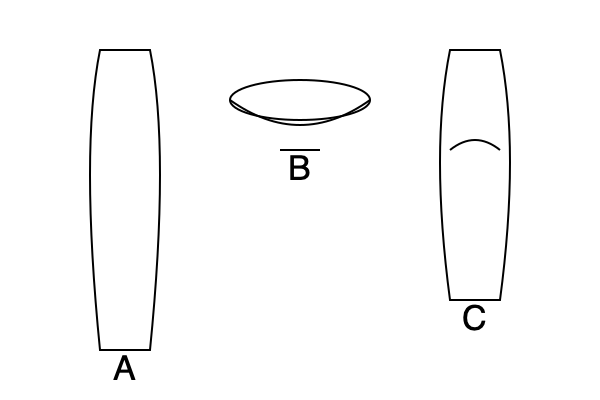Identify the ancient Greek pottery shapes illustrated in the image above and match them to their correct names: Amphora, Kylix, and Hydria. Which shape is specifically designed for mixing wine and water? To answer this question, we need to analyze the characteristics of each pottery shape and match them to their names:

1. Shape A: This is an Amphora. It has a tall, slender body with two handles and a narrow neck. Amphorae were primarily used for storing and transporting liquids like wine and olive oil.

2. Shape B: This is a Kylix. It's a wide, shallow drinking cup with a broad bowl, a stem, and a foot. The Kylix was specifically designed for drinking wine at symposia (ancient Greek drinking parties).

3. Shape C: This is a Hydria. It has a rounded body with three handles: two horizontal ones for lifting and a vertical one for pouring. Hydriae were primarily used for carrying water.

Among these shapes, the Kylix (Shape B) is specifically designed for mixing wine and water. Ancient Greeks typically diluted their wine with water in a large bowl called a krater, and then served it in smaller vessels like the Kylix. The wide, shallow bowl of the Kylix allowed for easy mixing and drinking of the diluted wine.

While the Hydria was used for water and the Amphora for storing wine, neither was specifically designed for mixing wine and water.
Answer: Kylix (Shape B) 